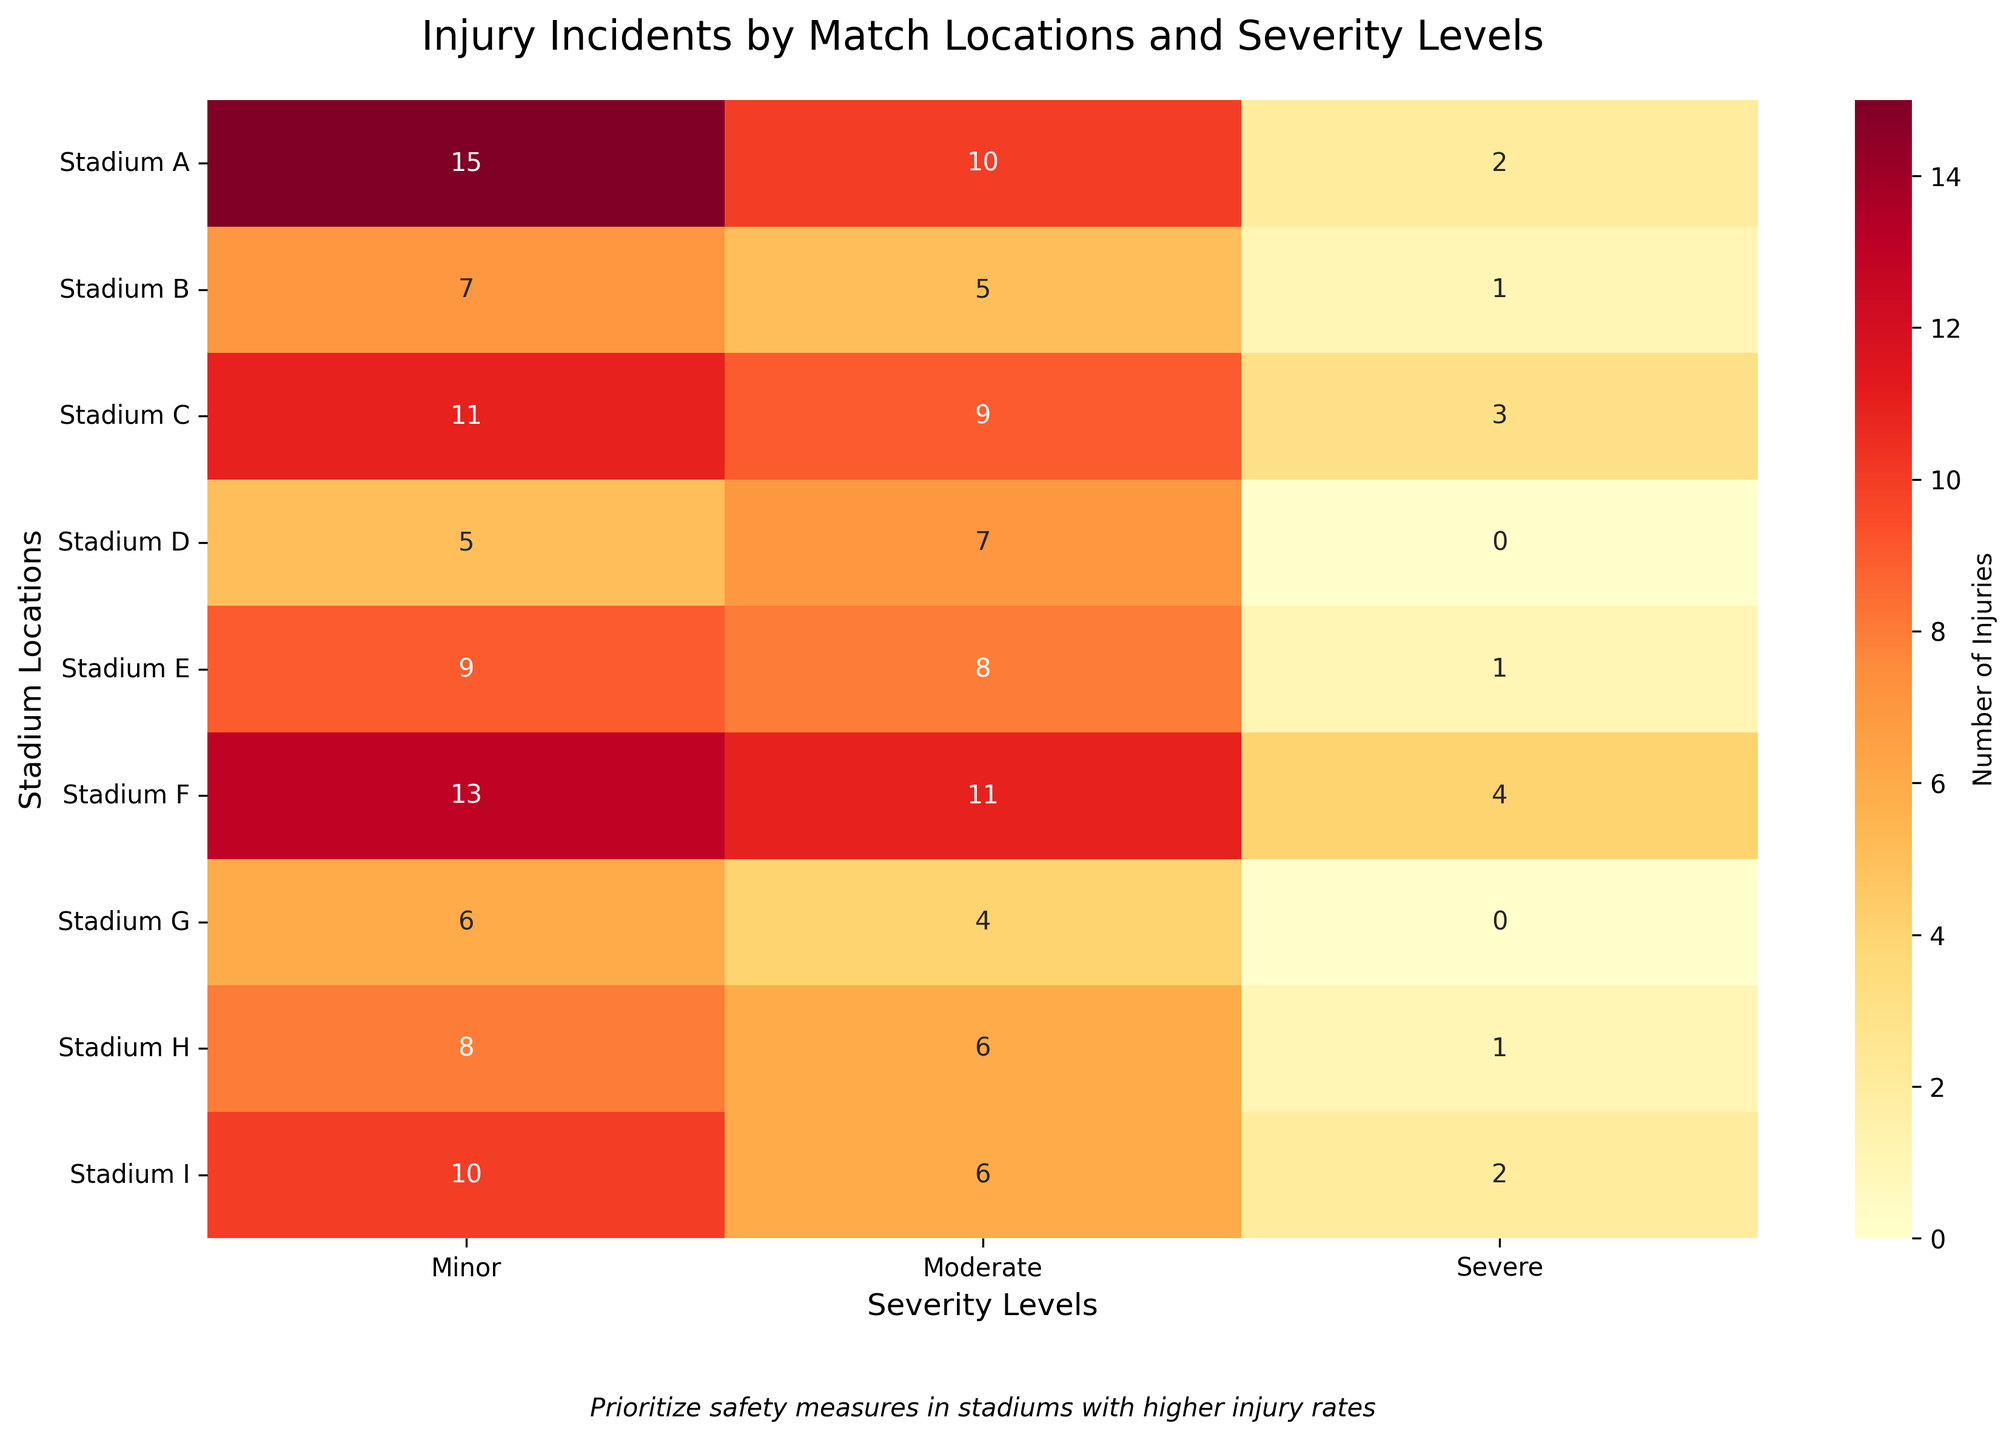What is the total number of minor injuries across all locations? To find the total number of minor injuries, add the minor injuries for all stadiums: 15 + 7 + 11 + 5 + 9 + 13 + 6 + 8 + 10 = 84.
Answer: 84 Which location has the highest number of severe injuries? Look at the 'Severe Injuries' column in the heatmap and find the stadium with the highest value: Stadium F has 4 severe injuries, which is the highest.
Answer: Stadium F What is the average number of moderate injuries per location? To calculate the average, sum the moderate injuries and divide by the number of locations: (10 + 5 + 9 + 7 + 8 + 11 + 4 + 6 + 6) / 9 = 66 / 9 ≈ 7.33.
Answer: 7.33 Which location has the lowest total number of injuries? Sum the minor, moderate, and severe injuries for each location and find the smallest sum. Stadium G: 6+4+0=10; Stadium G has the lowest total of 10 injuries.
Answer: Stadium G How many total injuries are recorded in Stadium A? Add minor, moderate, and severe injuries for Stadium A: 15 + 10 + 2 = 27.
Answer: 27 In which locations are there no severe injuries? Identify locations where the value in the 'Severe Injuries' column is 0. Stadiums D and G have 0 severe injuries.
Answer: Stadiums D and G Compare the total injuries between Stadium B and Stadium H. Which has more? Sum the injuries for each stadium, then compare: Stadium B: 7+5+1=13, Stadium H: 8+6+1=15. Stadium H has more total injuries.
Answer: Stadium H What is the total number of injuries recorded at Stadium E? Add the minor, moderate, and severe injuries at Stadium E: 9 + 8 + 1 = 18.
Answer: 18 How does the number of moderate injuries at Stadium C compare to Stadium I? Look at the 'Moderate Injuries' for both Stadiums: Stadium C has 9, Stadium I has 6. Stadium C has more moderate injuries.
Answer: Stadium C What is the difference in the number of minor injuries between Stadium F and Stadium A? Subtract the minor injuries of Stadium A from Stadium F: 13 - 15 = -2. Two less injuries in Stadium F compared to Stadium A.
Answer: -2 